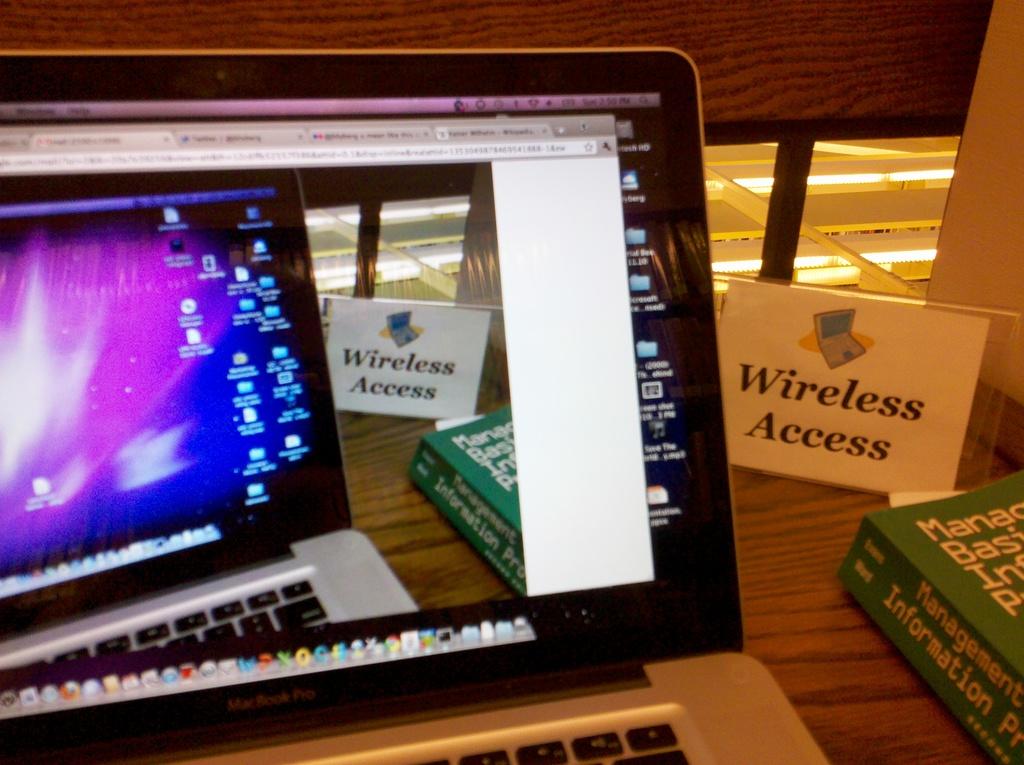What kind of access can you get here?
Give a very brief answer. Wireless. 